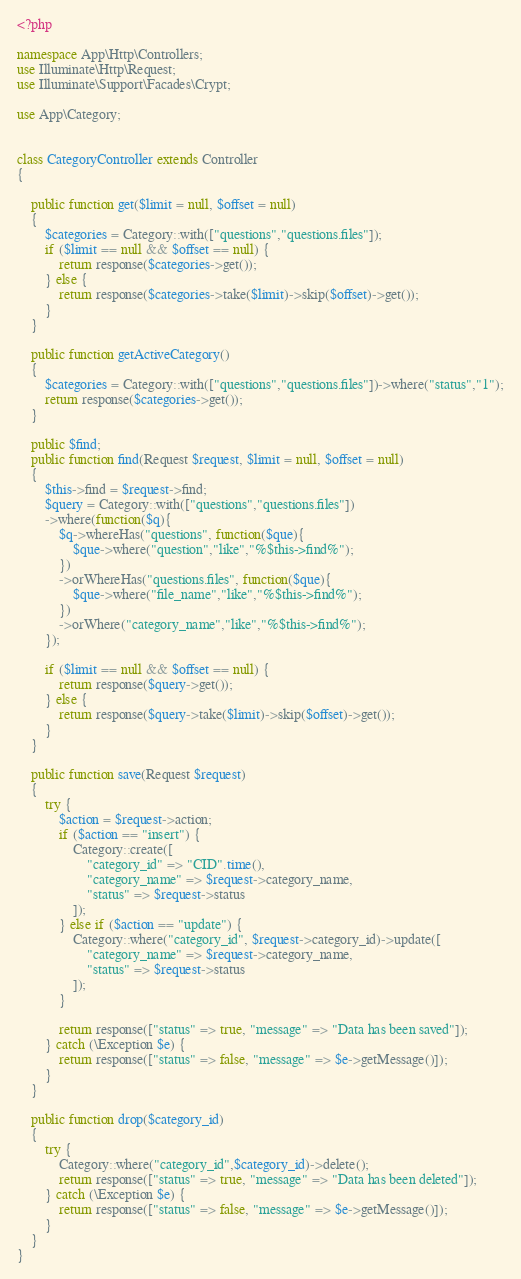<code> <loc_0><loc_0><loc_500><loc_500><_PHP_><?php

namespace App\Http\Controllers;
use Illuminate\Http\Request;
use Illuminate\Support\Facades\Crypt;

use App\Category;


class CategoryController extends Controller
{

    public function get($limit = null, $offset = null)
    {
        $categories = Category::with(["questions","questions.files"]);
        if ($limit == null && $offset == null) {
            return response($categories->get());
        } else {
            return response($categories->take($limit)->skip($offset)->get());
        }
    }

    public function getActiveCategory()
    {
        $categories = Category::with(["questions","questions.files"])->where("status","1");
        return response($categories->get());
    }

    public $find;
    public function find(Request $request, $limit = null, $offset = null)
    {
        $this->find = $request->find;
        $query = Category::with(["questions","questions.files"])
        ->where(function($q){
            $q->whereHas("questions", function($que){
                $que->where("question","like","%$this->find%");
            })
            ->orWhereHas("questions.files", function($que){
                $que->where("file_name","like","%$this->find%");
            })
            ->orWhere("category_name","like","%$this->find%");
        });
        
        if ($limit == null && $offset == null) {
            return response($query->get());
        } else {
            return response($query->take($limit)->skip($offset)->get());
        }
    }

    public function save(Request $request)
    {
        try {
            $action = $request->action;
            if ($action == "insert") {
                Category::create([
                    "category_id" => "CID".time(),
                    "category_name" => $request->category_name,
                    "status" => $request->status
                ]);
            } else if ($action == "update") {
                Category::where("category_id", $request->category_id)->update([
                    "category_name" => $request->category_name,
                    "status" => $request->status
                ]);
            }
            
            return response(["status" => true, "message" => "Data has been saved"]);
        } catch (\Exception $e) {
            return response(["status" => false, "message" => $e->getMessage()]);
        }
    }

    public function drop($category_id)
    {
        try {
            Category::where("category_id",$category_id)->delete();
            return response(["status" => true, "message" => "Data has been deleted"]);
        } catch (\Exception $e) {
            return response(["status" => false, "message" => $e->getMessage()]);
        }
    }
}
</code> 